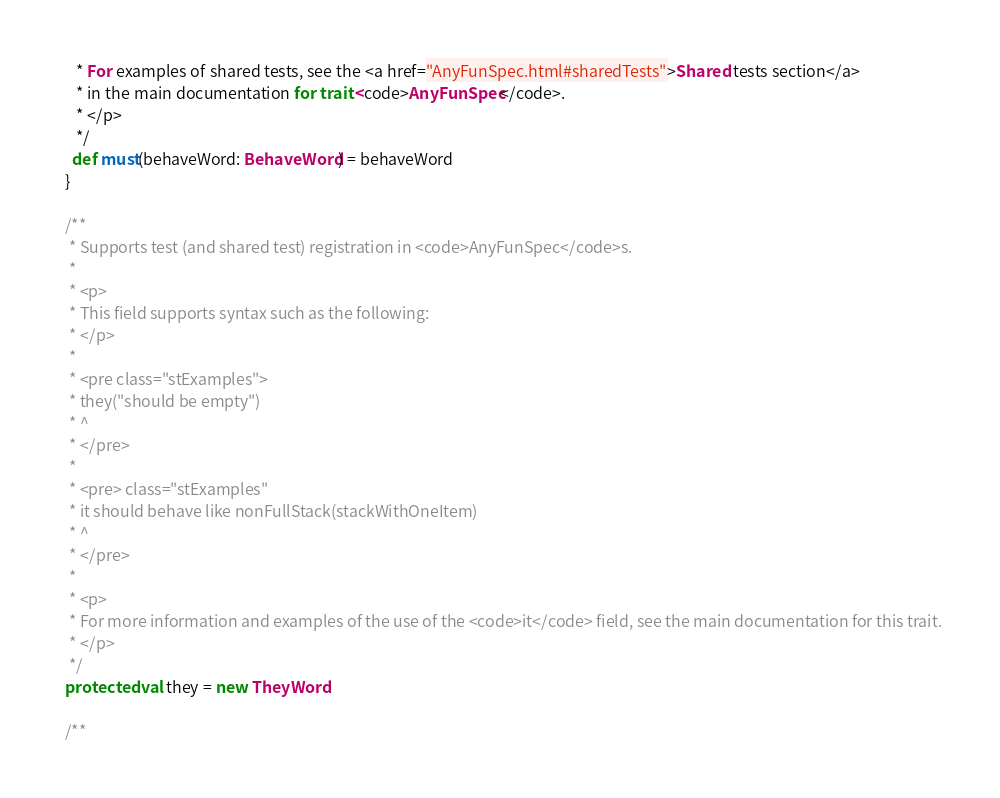Convert code to text. <code><loc_0><loc_0><loc_500><loc_500><_Scala_>     * For examples of shared tests, see the <a href="AnyFunSpec.html#sharedTests">Shared tests section</a>
     * in the main documentation for trait <code>AnyFunSpec</code>.
     * </p>
     */
    def must(behaveWord: BehaveWord) = behaveWord
  }

  /**
   * Supports test (and shared test) registration in <code>AnyFunSpec</code>s.
   *
   * <p>
   * This field supports syntax such as the following:
   * </p>
   *
   * <pre class="stExamples">
   * they("should be empty")
   * ^
   * </pre>
   *
   * <pre> class="stExamples"
   * it should behave like nonFullStack(stackWithOneItem)
   * ^
   * </pre>
   *
   * <p>
   * For more information and examples of the use of the <code>it</code> field, see the main documentation for this trait.
   * </p>
   */
  protected val they = new TheyWord

  /**</code> 